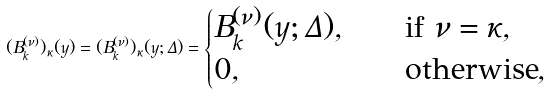<formula> <loc_0><loc_0><loc_500><loc_500>( B ^ { ( \nu ) } _ { k } ) _ { \kappa } ( y ) = ( B ^ { ( \nu ) } _ { k } ) _ { \kappa } ( y ; \Delta ) = \begin{cases} B ^ { ( \nu ) } _ { k } ( y ; \Delta ) , \quad & \text {if } \nu = \kappa , \\ 0 , & \text {otherwise} , \end{cases}</formula> 